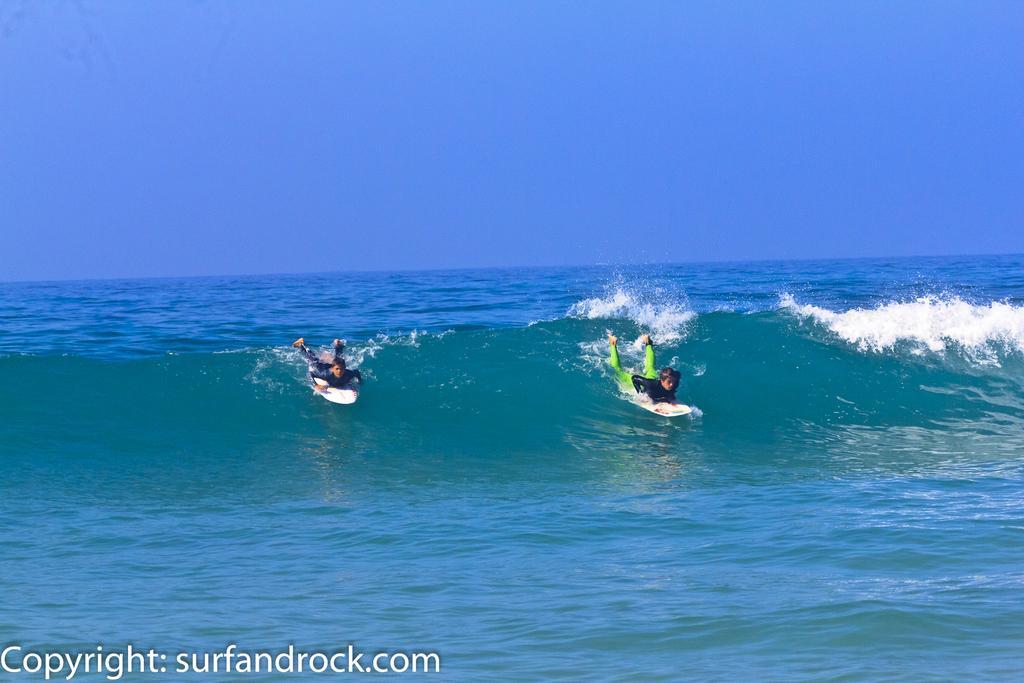Describe this image in one or two sentences. In this picture I can see two persons are surfing on the sea. At the bottom there is a watermark, at the top I can see the sky. 